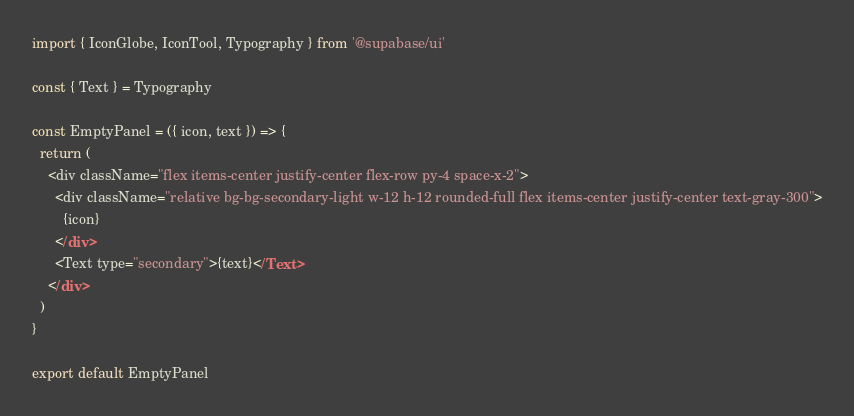Convert code to text. <code><loc_0><loc_0><loc_500><loc_500><_JavaScript_>import { IconGlobe, IconTool, Typography } from '@supabase/ui'

const { Text } = Typography

const EmptyPanel = ({ icon, text }) => {
  return (
    <div className="flex items-center justify-center flex-row py-4 space-x-2">
      <div className="relative bg-bg-secondary-light w-12 h-12 rounded-full flex items-center justify-center text-gray-300">
        {icon}
      </div>
      <Text type="secondary">{text}</Text>
    </div>
  )
}

export default EmptyPanel
</code> 